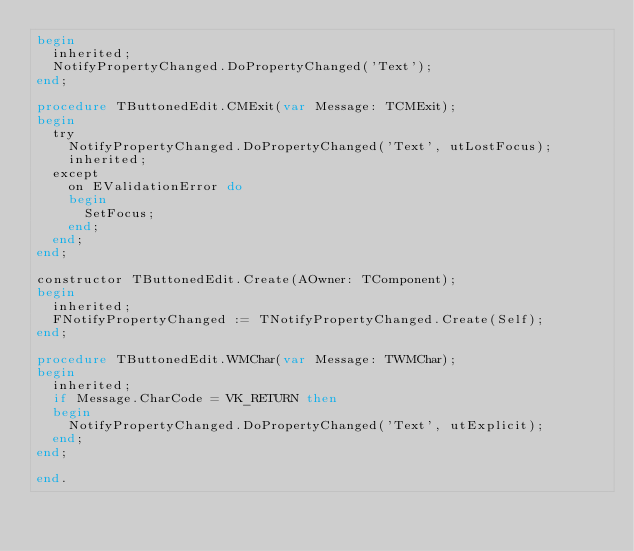<code> <loc_0><loc_0><loc_500><loc_500><_Pascal_>begin
  inherited;
  NotifyPropertyChanged.DoPropertyChanged('Text');
end;

procedure TButtonedEdit.CMExit(var Message: TCMExit);
begin
  try
    NotifyPropertyChanged.DoPropertyChanged('Text', utLostFocus);
    inherited;
  except
    on EValidationError do
    begin
      SetFocus;
    end;
  end;
end;

constructor TButtonedEdit.Create(AOwner: TComponent);
begin
  inherited;
  FNotifyPropertyChanged := TNotifyPropertyChanged.Create(Self);
end;

procedure TButtonedEdit.WMChar(var Message: TWMChar);
begin
  inherited;
  if Message.CharCode = VK_RETURN then
  begin
    NotifyPropertyChanged.DoPropertyChanged('Text', utExplicit);
  end;
end;

end.
</code> 